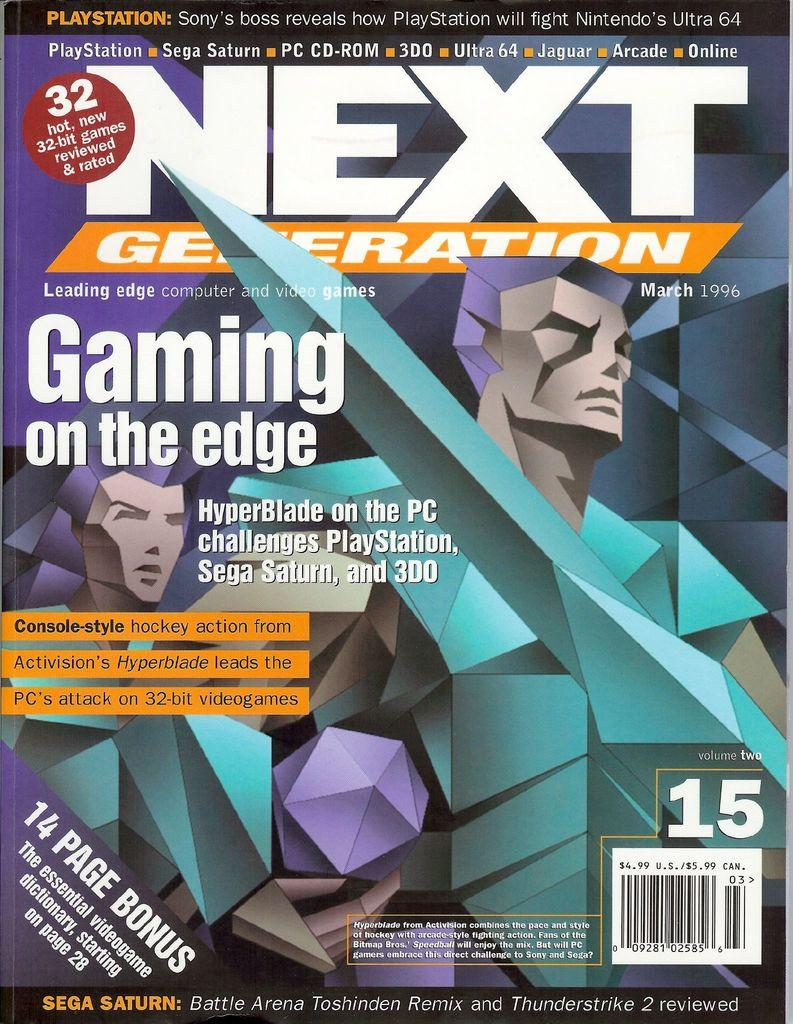<image>
Describe the image concisely. a magazine that says the Next Generation on it 